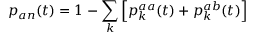Convert formula to latex. <formula><loc_0><loc_0><loc_500><loc_500>p _ { a n } ( t ) = 1 - \sum _ { k } \left [ p _ { k } ^ { a a } ( t ) + p _ { k } ^ { a b } ( t ) \right ]</formula> 